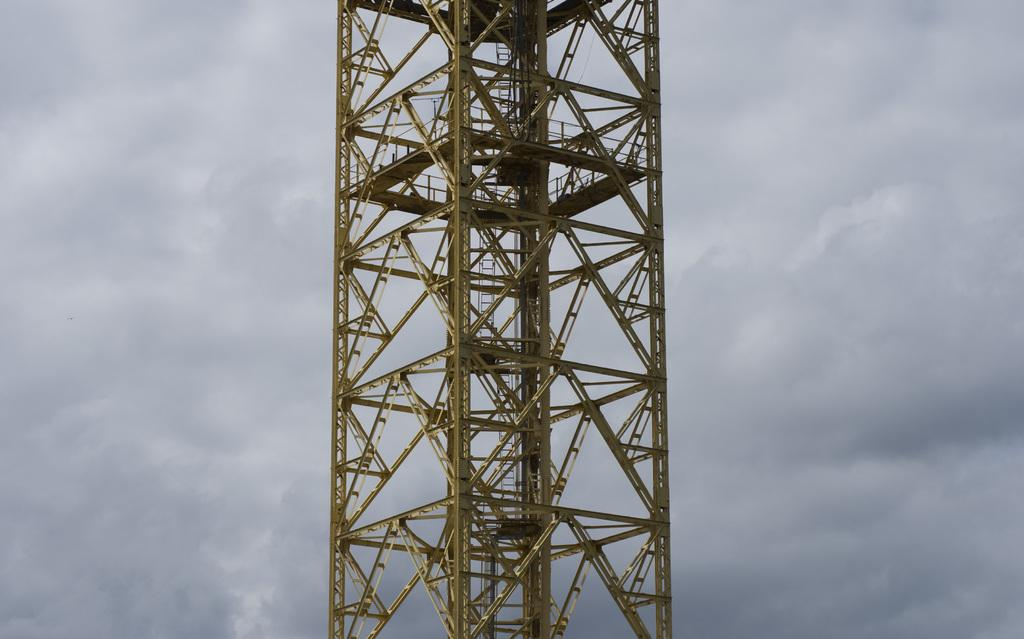What is the main subject in the center of the image? There is a tower in the center of the image. What can be seen in the background of the image? There are clouds in the sky in the background of the image. What type of ring does the queen wear in the image? There is no queen or ring present in the image. 